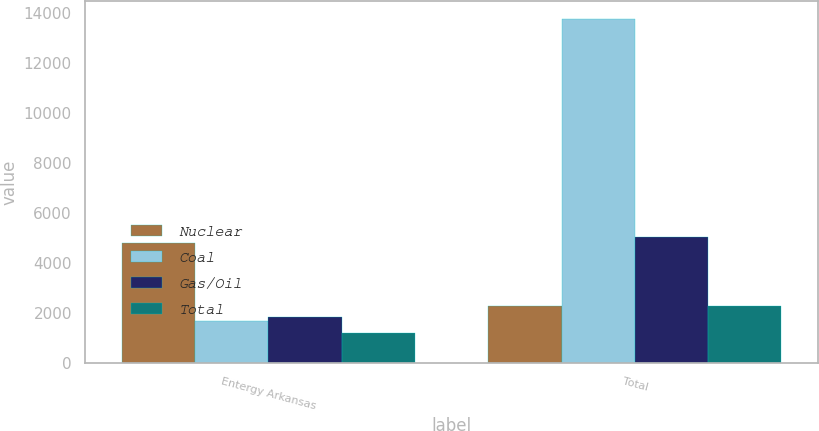<chart> <loc_0><loc_0><loc_500><loc_500><stacked_bar_chart><ecel><fcel>Entergy Arkansas<fcel>Total<nl><fcel>Nuclear<fcel>4774<fcel>2261<nl><fcel>Coal<fcel>1668<fcel>13755<nl><fcel>Gas/Oil<fcel>1823<fcel>5027<nl><fcel>Total<fcel>1209<fcel>2261<nl></chart> 